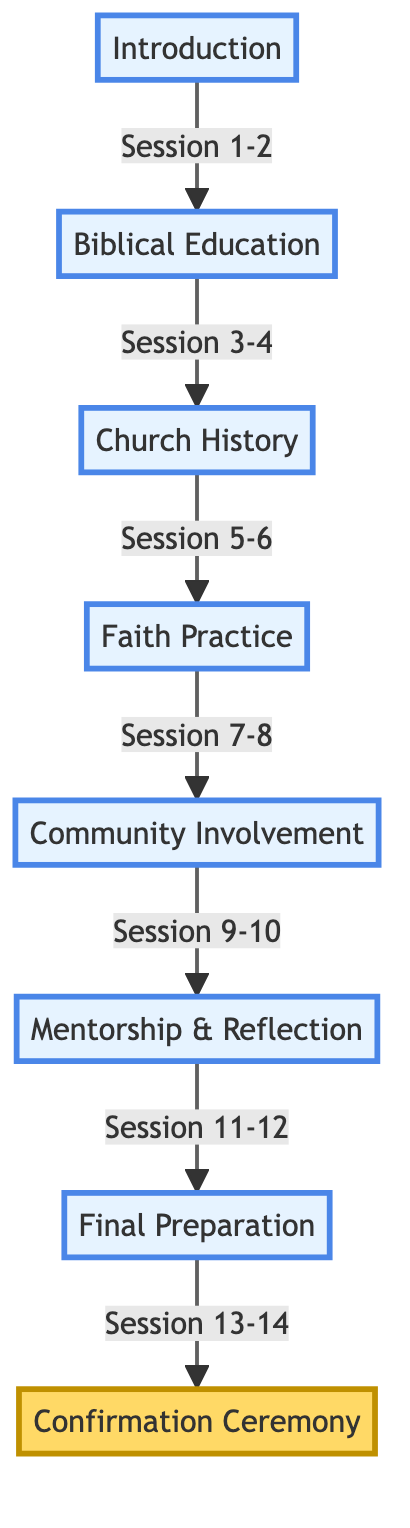What is the first session in the Confirmation Class Pathway? The diagram indicates that the first session is labeled "Session 1" under the "Introduction" phase, which is "Welcome to Confirmation - Get to know each other."
Answer: Welcome to Confirmation - Get to know each other How many sessions are there in total within the Confirmation Class Pathway? Counting the sessions listed in each phase (2 in Introduction, 2 in Biblical Education, 2 in Church History, 2 in Faith Practice, 2 in Community Involvement, 2 in Mentorship and Reflection, 2 in Final Preparation, and 1 in Confirmation Ceremony), we sum them to find there are 15 total sessions.
Answer: 15 Which phase follows "Community Involvement"? The flow shows that after "Community Involvement," the next phase is "Mentorship & Reflection." This is achieved by following the arrows from "Community Involvement."
Answer: Mentorship & Reflection What topics are covered in the "Biblical Education" phase? The "Biblical Education" phase consists of "Session 3 - Understanding the Bible - Old and New Testament Overview" and "Session 4 - Gospels Deep Dive - Life and Teachings of Jesus," which can be seen directly in the diagram.
Answer: Understanding the Bible - Old and New Testament Overview, Gospels Deep Dive - Life and Teachings of Jesus What is the last activity before the Confirmation Ceremony? According to the diagram, the last activity before the "Confirmation Ceremony" is "Confirmation Rehearsal and Final Q&A," which is listed as "Session 14" under the "Final Preparation" phase.
Answer: Confirmation Rehearsal and Final Q&A Which sessions are focused on personal growth and mentorship? In reviewing the "Mentorship & Reflection" phase, the sessions "Meet Your Mentor - Building Spiritual Relationships" and "Personal Reflection and Spiritual Growth" specifically address personal growth and mentorship.
Answer: Meet Your Mentor - Building Spiritual Relationships, Personal Reflection and Spiritual Growth How many phases are there in the Confirmation Class Pathway? By counting the distinct sections labeled in the diagram starting from "Introduction" to "Confirmation Ceremony," we find there are 7 phases.
Answer: 7 What is the main focus of the last phase in the pathway? The diagram reveals that the final phase labeled "Confirmation Ceremony" is primarily about "The Confirmation Ceremony - Celebrating Your Journey," indicating its focus on celebrating the confirmation event itself.
Answer: The Confirmation Ceremony - Celebrating Your Journey 